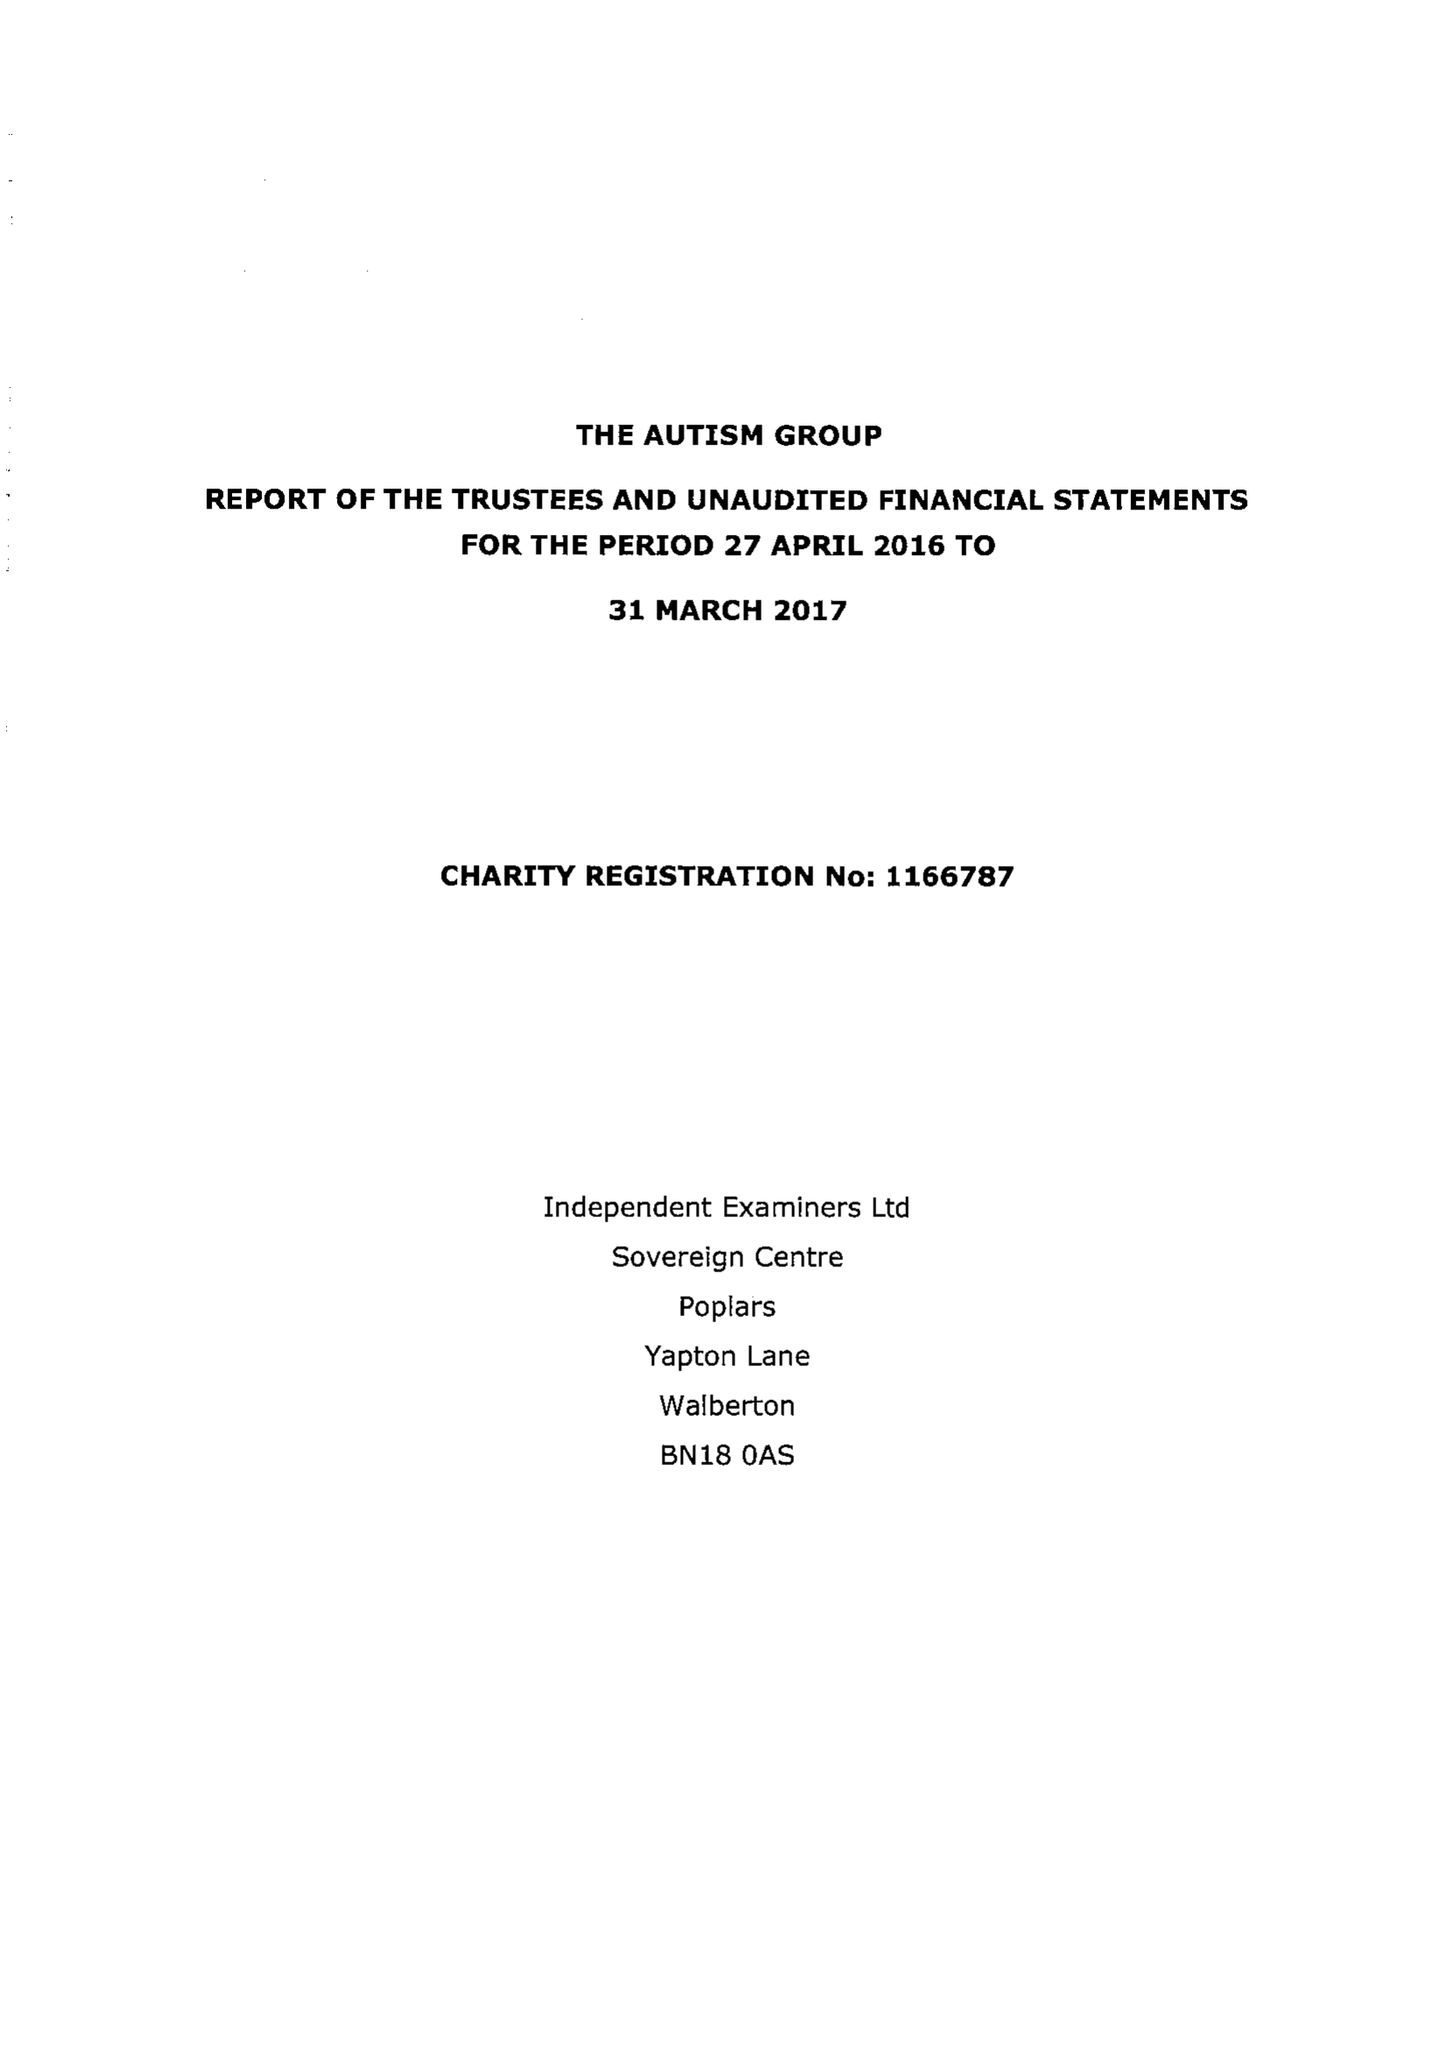What is the value for the charity_name?
Answer the question using a single word or phrase. The Autism Group 